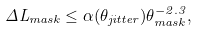Convert formula to latex. <formula><loc_0><loc_0><loc_500><loc_500>\Delta L _ { m a s k } \leq \alpha ( \theta _ { j i t t e r } ) \theta _ { m a s k } ^ { - 2 . 3 } ,</formula> 